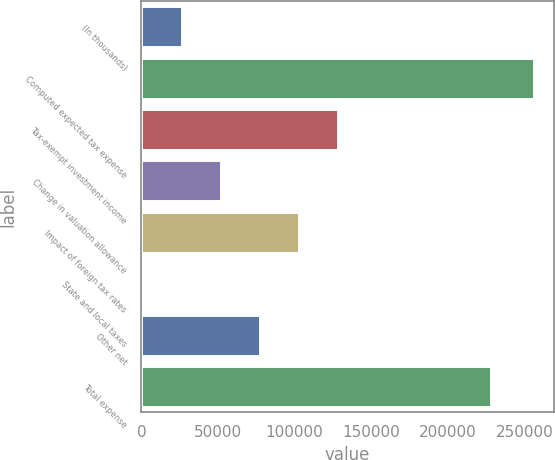<chart> <loc_0><loc_0><loc_500><loc_500><bar_chart><fcel>(In thousands)<fcel>Computed expected tax expense<fcel>Tax-exempt investment income<fcel>Change in valuation allowance<fcel>Impact of foreign tax rates<fcel>State and local taxes<fcel>Other net<fcel>Total expense<nl><fcel>26467<fcel>256210<fcel>128575<fcel>51994<fcel>103048<fcel>940<fcel>77521<fcel>227923<nl></chart> 